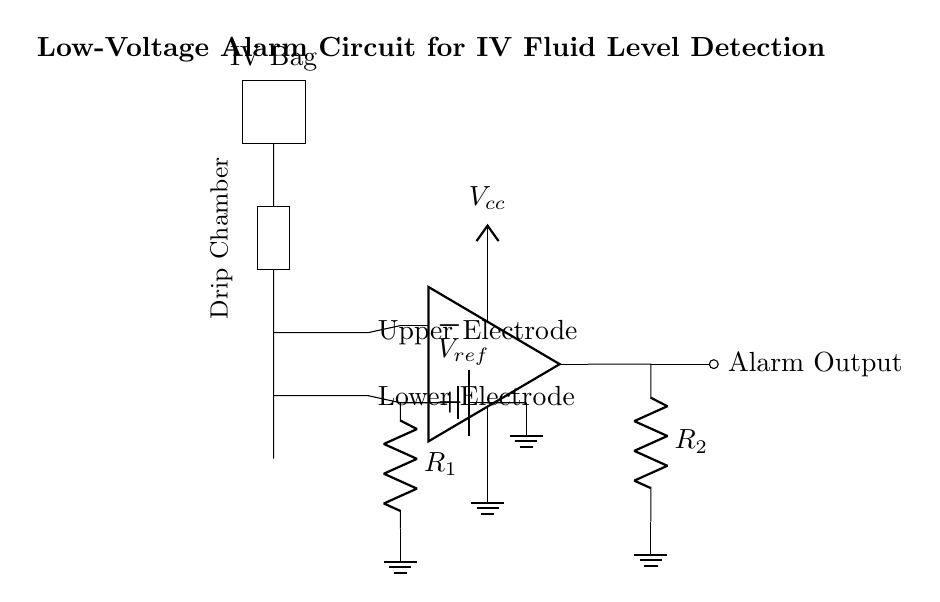What is the reference voltage in the circuit? The reference voltage, labeled as V_ref, is the voltage connected to the non-inverting input of the operational amplifier. It influences the comparison with the inputs from the electrodes.
Answer: V_ref What type of amplifier is used in this circuit? The circuit uses an operational amplifier, indicated by the symbol "op amp" in the diagram. It serves to compare the voltages from the electrodes.
Answer: Operational amplifier How many electrodes are included in the circuit? There are two electrodes: an upper electrode and a lower electrode, as seen on the right side of the circuit diagram.
Answer: Two What component generates the alarm signal? The alarm output is generated when the operational amplifier output is activated, which is indicated by the label "Alarm Output" next to the ocirc symbol in the diagram.
Answer: Operational amplifier output What does R_1 connect to in the circuit? Resistor R_1 connects the inverting input of the operational amplifier to ground, forming a reference point for voltage comparison with the positive input.
Answer: Ground What is the role of the drip chamber in this circuit? The drip chamber serves an essential function as it contains the IV fluid and impacts the conductivity between the two electrodes, which the circuit monitors for detection of fluid levels.
Answer: Fluid level detection What is the purpose of R_2 in this circuit? Resistor R_2 is connected to the output of the operational amplifier, and it helps to limit the current to the alarm output, ensuring safe operation of the circuit.
Answer: Current limiting 